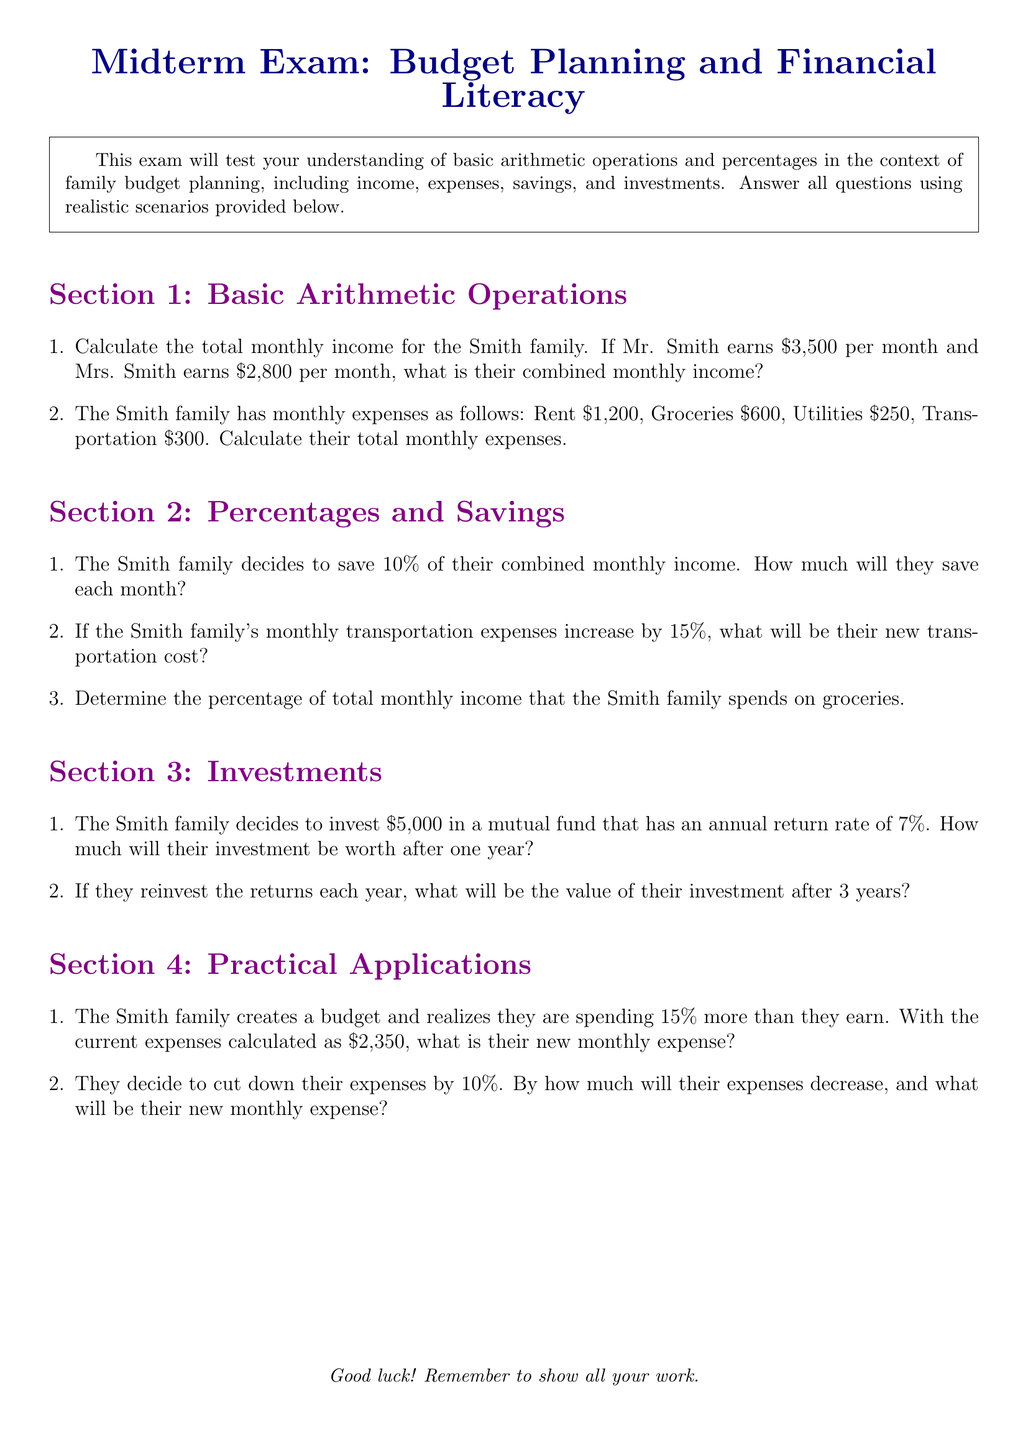What is the Smith family's combined monthly income? The combined monthly income is the sum of Mr. Smith's income ($3,500) and Mrs. Smith's income ($2,800).
Answer: $6,300 What are the total monthly expenses for the Smith family? To find the total monthly expenses, add all the listed expenses: Rent (\$1,200) + Groceries (\$600) + Utilities (\$250) + Transportation (\$300).
Answer: $2,350 How much will the Smith family save each month? The savings amount is calculated as 10% of their combined monthly income, which is \$6,300.
Answer: $630 What will be the new transportation cost after a 15% increase? To find the new transportation cost, calculate 15% of the current cost (\$300) and add it to the original amount.
Answer: $345 What percentage of total monthly income does the Smith family spend on groceries? To determine the percentage, divide the groceries expense (\$600) by the total income (\$6,300) and multiply by 100.
Answer: 9.52% What is the value of the Smith family's investment after one year? The value after one year is calculated by adding the annual return (7% of \$5,000) to the original investment.
Answer: $5,350 What is the new monthly expense if they are spending 15% more than they earn? The new monthly expense is calculated by adding 15% to their current expenses (\$2,350).
Answer: $2,702.50 By how much will the Smith family’s expenses decrease with a 10% cut? To find the decrease, calculate 10% of the current expenses (\$2,350) and indicate how much it will reduce the total.
Answer: $235 What will be their new monthly expense after the 10% decrease? The new monthly expense is calculated by subtracting the decrease from the current expenses (\$2,350).
Answer: $2,115 